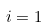<formula> <loc_0><loc_0><loc_500><loc_500>i = 1</formula> 